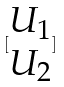<formula> <loc_0><loc_0><loc_500><loc_500>[ \begin{matrix} U _ { 1 } \\ U _ { 2 } \end{matrix} ]</formula> 